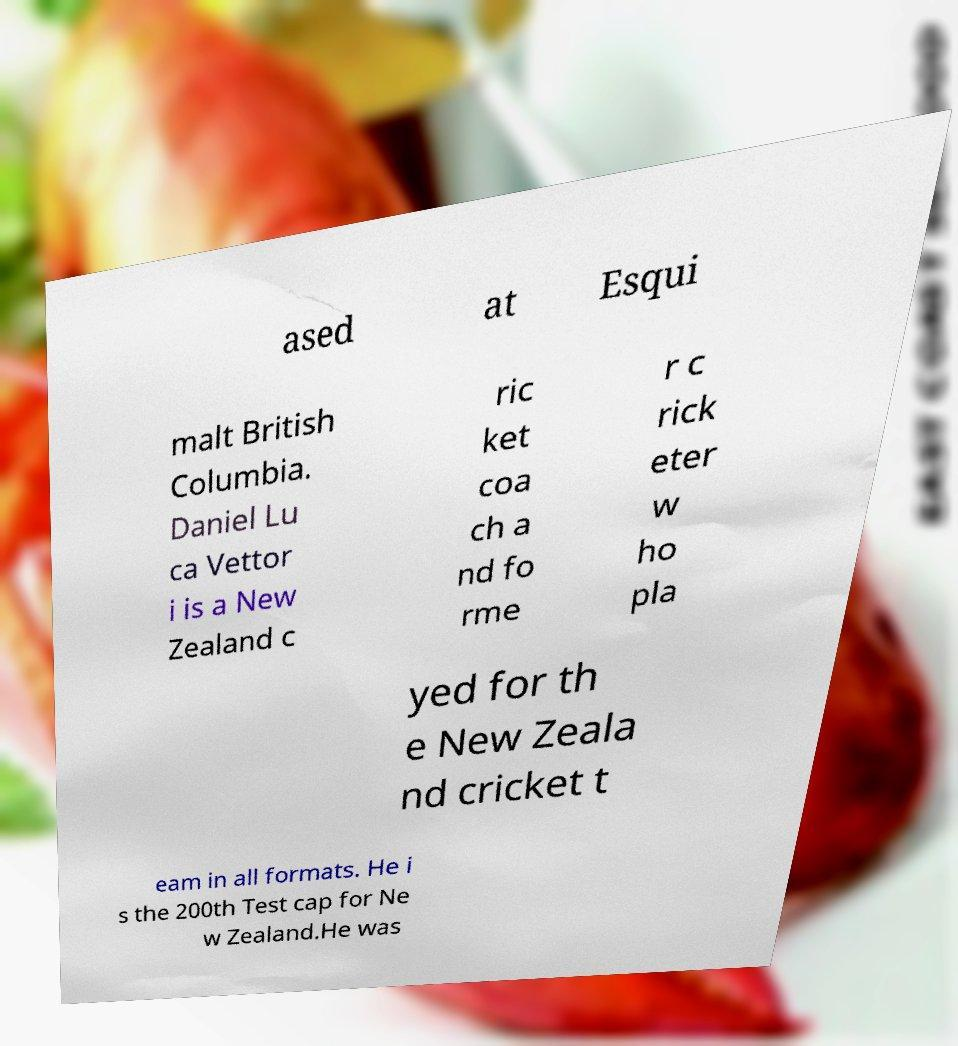Can you read and provide the text displayed in the image?This photo seems to have some interesting text. Can you extract and type it out for me? ased at Esqui malt British Columbia. Daniel Lu ca Vettor i is a New Zealand c ric ket coa ch a nd fo rme r c rick eter w ho pla yed for th e New Zeala nd cricket t eam in all formats. He i s the 200th Test cap for Ne w Zealand.He was 